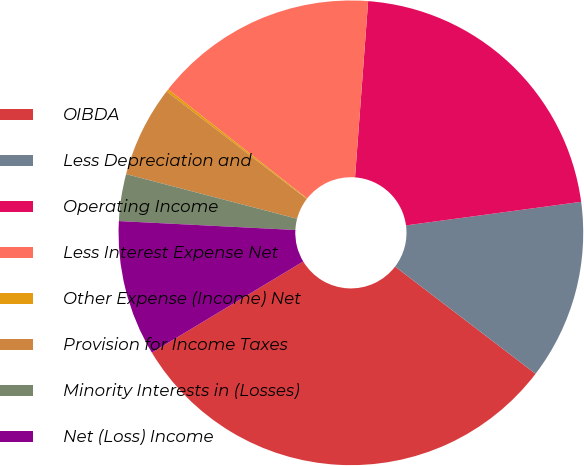Convert chart to OTSL. <chart><loc_0><loc_0><loc_500><loc_500><pie_chart><fcel>OIBDA<fcel>Less Depreciation and<fcel>Operating Income<fcel>Less Interest Expense Net<fcel>Other Expense (Income) Net<fcel>Provision for Income Taxes<fcel>Minority Interests in (Losses)<fcel>Net (Loss) Income<nl><fcel>31.0%<fcel>12.51%<fcel>21.69%<fcel>15.59%<fcel>0.18%<fcel>6.35%<fcel>3.26%<fcel>9.43%<nl></chart> 